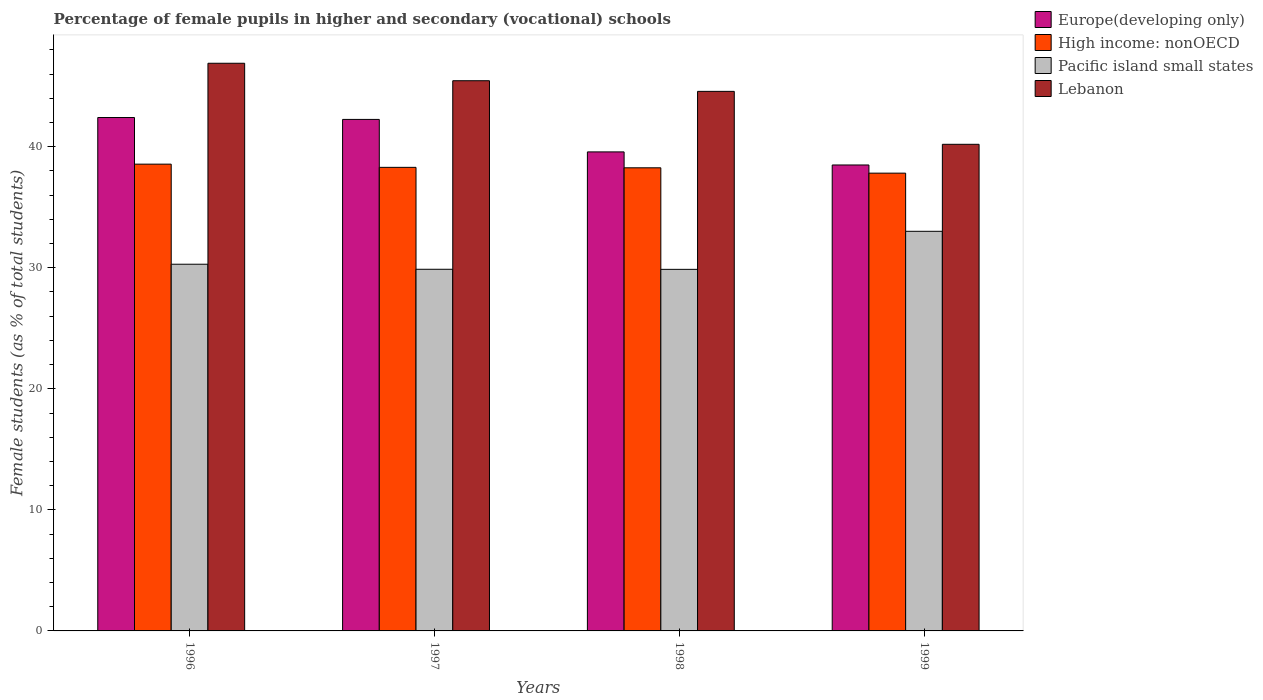How many groups of bars are there?
Ensure brevity in your answer.  4. Are the number of bars per tick equal to the number of legend labels?
Your answer should be compact. Yes. Are the number of bars on each tick of the X-axis equal?
Offer a very short reply. Yes. What is the percentage of female pupils in higher and secondary schools in Pacific island small states in 1999?
Keep it short and to the point. 33.01. Across all years, what is the maximum percentage of female pupils in higher and secondary schools in Lebanon?
Provide a short and direct response. 46.9. Across all years, what is the minimum percentage of female pupils in higher and secondary schools in Europe(developing only)?
Your answer should be very brief. 38.49. In which year was the percentage of female pupils in higher and secondary schools in Europe(developing only) maximum?
Give a very brief answer. 1996. In which year was the percentage of female pupils in higher and secondary schools in Pacific island small states minimum?
Your answer should be compact. 1998. What is the total percentage of female pupils in higher and secondary schools in Europe(developing only) in the graph?
Offer a terse response. 162.74. What is the difference between the percentage of female pupils in higher and secondary schools in Pacific island small states in 1998 and that in 1999?
Ensure brevity in your answer.  -3.14. What is the difference between the percentage of female pupils in higher and secondary schools in High income: nonOECD in 1996 and the percentage of female pupils in higher and secondary schools in Europe(developing only) in 1999?
Provide a short and direct response. 0.07. What is the average percentage of female pupils in higher and secondary schools in Pacific island small states per year?
Offer a very short reply. 30.76. In the year 1996, what is the difference between the percentage of female pupils in higher and secondary schools in High income: nonOECD and percentage of female pupils in higher and secondary schools in Pacific island small states?
Ensure brevity in your answer.  8.27. In how many years, is the percentage of female pupils in higher and secondary schools in Pacific island small states greater than 2 %?
Ensure brevity in your answer.  4. What is the ratio of the percentage of female pupils in higher and secondary schools in Europe(developing only) in 1996 to that in 1997?
Offer a very short reply. 1. What is the difference between the highest and the second highest percentage of female pupils in higher and secondary schools in Europe(developing only)?
Offer a terse response. 0.16. What is the difference between the highest and the lowest percentage of female pupils in higher and secondary schools in Lebanon?
Your response must be concise. 6.7. In how many years, is the percentage of female pupils in higher and secondary schools in High income: nonOECD greater than the average percentage of female pupils in higher and secondary schools in High income: nonOECD taken over all years?
Your answer should be very brief. 3. Is the sum of the percentage of female pupils in higher and secondary schools in Europe(developing only) in 1997 and 1999 greater than the maximum percentage of female pupils in higher and secondary schools in Pacific island small states across all years?
Make the answer very short. Yes. Is it the case that in every year, the sum of the percentage of female pupils in higher and secondary schools in Pacific island small states and percentage of female pupils in higher and secondary schools in Lebanon is greater than the sum of percentage of female pupils in higher and secondary schools in Europe(developing only) and percentage of female pupils in higher and secondary schools in High income: nonOECD?
Your answer should be compact. Yes. What does the 1st bar from the left in 1996 represents?
Offer a terse response. Europe(developing only). What does the 4th bar from the right in 1998 represents?
Give a very brief answer. Europe(developing only). Is it the case that in every year, the sum of the percentage of female pupils in higher and secondary schools in Pacific island small states and percentage of female pupils in higher and secondary schools in High income: nonOECD is greater than the percentage of female pupils in higher and secondary schools in Europe(developing only)?
Offer a terse response. Yes. How many bars are there?
Offer a very short reply. 16. How many years are there in the graph?
Provide a succinct answer. 4. Are the values on the major ticks of Y-axis written in scientific E-notation?
Your answer should be very brief. No. Does the graph contain grids?
Your response must be concise. No. How many legend labels are there?
Your answer should be very brief. 4. How are the legend labels stacked?
Make the answer very short. Vertical. What is the title of the graph?
Offer a very short reply. Percentage of female pupils in higher and secondary (vocational) schools. Does "Kenya" appear as one of the legend labels in the graph?
Offer a very short reply. No. What is the label or title of the Y-axis?
Your answer should be very brief. Female students (as % of total students). What is the Female students (as % of total students) of Europe(developing only) in 1996?
Your answer should be very brief. 42.41. What is the Female students (as % of total students) of High income: nonOECD in 1996?
Offer a very short reply. 38.56. What is the Female students (as % of total students) of Pacific island small states in 1996?
Ensure brevity in your answer.  30.29. What is the Female students (as % of total students) in Lebanon in 1996?
Your answer should be very brief. 46.9. What is the Female students (as % of total students) of Europe(developing only) in 1997?
Give a very brief answer. 42.26. What is the Female students (as % of total students) in High income: nonOECD in 1997?
Ensure brevity in your answer.  38.3. What is the Female students (as % of total students) of Pacific island small states in 1997?
Provide a succinct answer. 29.88. What is the Female students (as % of total students) of Lebanon in 1997?
Provide a succinct answer. 45.45. What is the Female students (as % of total students) in Europe(developing only) in 1998?
Give a very brief answer. 39.57. What is the Female students (as % of total students) of High income: nonOECD in 1998?
Offer a very short reply. 38.26. What is the Female students (as % of total students) of Pacific island small states in 1998?
Your answer should be very brief. 29.87. What is the Female students (as % of total students) in Lebanon in 1998?
Make the answer very short. 44.57. What is the Female students (as % of total students) of Europe(developing only) in 1999?
Your answer should be compact. 38.49. What is the Female students (as % of total students) of High income: nonOECD in 1999?
Your answer should be compact. 37.82. What is the Female students (as % of total students) of Pacific island small states in 1999?
Offer a very short reply. 33.01. What is the Female students (as % of total students) of Lebanon in 1999?
Offer a very short reply. 40.2. Across all years, what is the maximum Female students (as % of total students) in Europe(developing only)?
Your answer should be very brief. 42.41. Across all years, what is the maximum Female students (as % of total students) in High income: nonOECD?
Give a very brief answer. 38.56. Across all years, what is the maximum Female students (as % of total students) in Pacific island small states?
Make the answer very short. 33.01. Across all years, what is the maximum Female students (as % of total students) of Lebanon?
Keep it short and to the point. 46.9. Across all years, what is the minimum Female students (as % of total students) of Europe(developing only)?
Ensure brevity in your answer.  38.49. Across all years, what is the minimum Female students (as % of total students) of High income: nonOECD?
Keep it short and to the point. 37.82. Across all years, what is the minimum Female students (as % of total students) in Pacific island small states?
Your answer should be very brief. 29.87. Across all years, what is the minimum Female students (as % of total students) in Lebanon?
Provide a short and direct response. 40.2. What is the total Female students (as % of total students) of Europe(developing only) in the graph?
Offer a terse response. 162.74. What is the total Female students (as % of total students) in High income: nonOECD in the graph?
Provide a short and direct response. 152.94. What is the total Female students (as % of total students) of Pacific island small states in the graph?
Provide a short and direct response. 123.06. What is the total Female students (as % of total students) in Lebanon in the graph?
Your answer should be compact. 177.13. What is the difference between the Female students (as % of total students) in Europe(developing only) in 1996 and that in 1997?
Your answer should be compact. 0.16. What is the difference between the Female students (as % of total students) of High income: nonOECD in 1996 and that in 1997?
Offer a very short reply. 0.26. What is the difference between the Female students (as % of total students) of Pacific island small states in 1996 and that in 1997?
Offer a terse response. 0.42. What is the difference between the Female students (as % of total students) in Lebanon in 1996 and that in 1997?
Ensure brevity in your answer.  1.44. What is the difference between the Female students (as % of total students) of Europe(developing only) in 1996 and that in 1998?
Your answer should be very brief. 2.84. What is the difference between the Female students (as % of total students) of High income: nonOECD in 1996 and that in 1998?
Give a very brief answer. 0.3. What is the difference between the Female students (as % of total students) in Pacific island small states in 1996 and that in 1998?
Make the answer very short. 0.42. What is the difference between the Female students (as % of total students) of Lebanon in 1996 and that in 1998?
Make the answer very short. 2.32. What is the difference between the Female students (as % of total students) in Europe(developing only) in 1996 and that in 1999?
Your response must be concise. 3.92. What is the difference between the Female students (as % of total students) of High income: nonOECD in 1996 and that in 1999?
Provide a succinct answer. 0.74. What is the difference between the Female students (as % of total students) in Pacific island small states in 1996 and that in 1999?
Ensure brevity in your answer.  -2.72. What is the difference between the Female students (as % of total students) of Lebanon in 1996 and that in 1999?
Keep it short and to the point. 6.7. What is the difference between the Female students (as % of total students) of Europe(developing only) in 1997 and that in 1998?
Offer a terse response. 2.68. What is the difference between the Female students (as % of total students) of High income: nonOECD in 1997 and that in 1998?
Offer a terse response. 0.04. What is the difference between the Female students (as % of total students) in Pacific island small states in 1997 and that in 1998?
Provide a short and direct response. 0.01. What is the difference between the Female students (as % of total students) in Lebanon in 1997 and that in 1998?
Provide a succinct answer. 0.88. What is the difference between the Female students (as % of total students) in Europe(developing only) in 1997 and that in 1999?
Your response must be concise. 3.76. What is the difference between the Female students (as % of total students) of High income: nonOECD in 1997 and that in 1999?
Provide a succinct answer. 0.48. What is the difference between the Female students (as % of total students) of Pacific island small states in 1997 and that in 1999?
Ensure brevity in your answer.  -3.14. What is the difference between the Female students (as % of total students) of Lebanon in 1997 and that in 1999?
Provide a succinct answer. 5.25. What is the difference between the Female students (as % of total students) in Europe(developing only) in 1998 and that in 1999?
Give a very brief answer. 1.08. What is the difference between the Female students (as % of total students) in High income: nonOECD in 1998 and that in 1999?
Make the answer very short. 0.44. What is the difference between the Female students (as % of total students) of Pacific island small states in 1998 and that in 1999?
Keep it short and to the point. -3.14. What is the difference between the Female students (as % of total students) in Lebanon in 1998 and that in 1999?
Offer a terse response. 4.37. What is the difference between the Female students (as % of total students) of Europe(developing only) in 1996 and the Female students (as % of total students) of High income: nonOECD in 1997?
Offer a very short reply. 4.12. What is the difference between the Female students (as % of total students) of Europe(developing only) in 1996 and the Female students (as % of total students) of Pacific island small states in 1997?
Make the answer very short. 12.54. What is the difference between the Female students (as % of total students) of Europe(developing only) in 1996 and the Female students (as % of total students) of Lebanon in 1997?
Your answer should be compact. -3.04. What is the difference between the Female students (as % of total students) of High income: nonOECD in 1996 and the Female students (as % of total students) of Pacific island small states in 1997?
Offer a terse response. 8.69. What is the difference between the Female students (as % of total students) of High income: nonOECD in 1996 and the Female students (as % of total students) of Lebanon in 1997?
Offer a very short reply. -6.89. What is the difference between the Female students (as % of total students) of Pacific island small states in 1996 and the Female students (as % of total students) of Lebanon in 1997?
Keep it short and to the point. -15.16. What is the difference between the Female students (as % of total students) in Europe(developing only) in 1996 and the Female students (as % of total students) in High income: nonOECD in 1998?
Your response must be concise. 4.15. What is the difference between the Female students (as % of total students) of Europe(developing only) in 1996 and the Female students (as % of total students) of Pacific island small states in 1998?
Your answer should be very brief. 12.54. What is the difference between the Female students (as % of total students) in Europe(developing only) in 1996 and the Female students (as % of total students) in Lebanon in 1998?
Your answer should be very brief. -2.16. What is the difference between the Female students (as % of total students) in High income: nonOECD in 1996 and the Female students (as % of total students) in Pacific island small states in 1998?
Offer a terse response. 8.69. What is the difference between the Female students (as % of total students) of High income: nonOECD in 1996 and the Female students (as % of total students) of Lebanon in 1998?
Make the answer very short. -6.01. What is the difference between the Female students (as % of total students) in Pacific island small states in 1996 and the Female students (as % of total students) in Lebanon in 1998?
Ensure brevity in your answer.  -14.28. What is the difference between the Female students (as % of total students) of Europe(developing only) in 1996 and the Female students (as % of total students) of High income: nonOECD in 1999?
Provide a short and direct response. 4.6. What is the difference between the Female students (as % of total students) in Europe(developing only) in 1996 and the Female students (as % of total students) in Pacific island small states in 1999?
Your response must be concise. 9.4. What is the difference between the Female students (as % of total students) of Europe(developing only) in 1996 and the Female students (as % of total students) of Lebanon in 1999?
Give a very brief answer. 2.21. What is the difference between the Female students (as % of total students) in High income: nonOECD in 1996 and the Female students (as % of total students) in Pacific island small states in 1999?
Provide a short and direct response. 5.55. What is the difference between the Female students (as % of total students) in High income: nonOECD in 1996 and the Female students (as % of total students) in Lebanon in 1999?
Give a very brief answer. -1.64. What is the difference between the Female students (as % of total students) in Pacific island small states in 1996 and the Female students (as % of total students) in Lebanon in 1999?
Provide a succinct answer. -9.91. What is the difference between the Female students (as % of total students) of Europe(developing only) in 1997 and the Female students (as % of total students) of High income: nonOECD in 1998?
Provide a short and direct response. 4. What is the difference between the Female students (as % of total students) in Europe(developing only) in 1997 and the Female students (as % of total students) in Pacific island small states in 1998?
Ensure brevity in your answer.  12.39. What is the difference between the Female students (as % of total students) of Europe(developing only) in 1997 and the Female students (as % of total students) of Lebanon in 1998?
Give a very brief answer. -2.32. What is the difference between the Female students (as % of total students) in High income: nonOECD in 1997 and the Female students (as % of total students) in Pacific island small states in 1998?
Offer a very short reply. 8.43. What is the difference between the Female students (as % of total students) in High income: nonOECD in 1997 and the Female students (as % of total students) in Lebanon in 1998?
Provide a succinct answer. -6.28. What is the difference between the Female students (as % of total students) of Pacific island small states in 1997 and the Female students (as % of total students) of Lebanon in 1998?
Offer a terse response. -14.7. What is the difference between the Female students (as % of total students) in Europe(developing only) in 1997 and the Female students (as % of total students) in High income: nonOECD in 1999?
Provide a succinct answer. 4.44. What is the difference between the Female students (as % of total students) in Europe(developing only) in 1997 and the Female students (as % of total students) in Pacific island small states in 1999?
Give a very brief answer. 9.24. What is the difference between the Female students (as % of total students) of Europe(developing only) in 1997 and the Female students (as % of total students) of Lebanon in 1999?
Provide a succinct answer. 2.06. What is the difference between the Female students (as % of total students) in High income: nonOECD in 1997 and the Female students (as % of total students) in Pacific island small states in 1999?
Provide a short and direct response. 5.28. What is the difference between the Female students (as % of total students) of High income: nonOECD in 1997 and the Female students (as % of total students) of Lebanon in 1999?
Provide a succinct answer. -1.9. What is the difference between the Female students (as % of total students) in Pacific island small states in 1997 and the Female students (as % of total students) in Lebanon in 1999?
Your response must be concise. -10.32. What is the difference between the Female students (as % of total students) of Europe(developing only) in 1998 and the Female students (as % of total students) of High income: nonOECD in 1999?
Make the answer very short. 1.76. What is the difference between the Female students (as % of total students) of Europe(developing only) in 1998 and the Female students (as % of total students) of Pacific island small states in 1999?
Your answer should be very brief. 6.56. What is the difference between the Female students (as % of total students) of Europe(developing only) in 1998 and the Female students (as % of total students) of Lebanon in 1999?
Ensure brevity in your answer.  -0.63. What is the difference between the Female students (as % of total students) of High income: nonOECD in 1998 and the Female students (as % of total students) of Pacific island small states in 1999?
Your answer should be very brief. 5.24. What is the difference between the Female students (as % of total students) of High income: nonOECD in 1998 and the Female students (as % of total students) of Lebanon in 1999?
Give a very brief answer. -1.94. What is the difference between the Female students (as % of total students) in Pacific island small states in 1998 and the Female students (as % of total students) in Lebanon in 1999?
Give a very brief answer. -10.33. What is the average Female students (as % of total students) of Europe(developing only) per year?
Make the answer very short. 40.68. What is the average Female students (as % of total students) in High income: nonOECD per year?
Make the answer very short. 38.23. What is the average Female students (as % of total students) in Pacific island small states per year?
Provide a succinct answer. 30.76. What is the average Female students (as % of total students) of Lebanon per year?
Your answer should be compact. 44.28. In the year 1996, what is the difference between the Female students (as % of total students) of Europe(developing only) and Female students (as % of total students) of High income: nonOECD?
Your answer should be compact. 3.85. In the year 1996, what is the difference between the Female students (as % of total students) of Europe(developing only) and Female students (as % of total students) of Pacific island small states?
Offer a very short reply. 12.12. In the year 1996, what is the difference between the Female students (as % of total students) in Europe(developing only) and Female students (as % of total students) in Lebanon?
Provide a succinct answer. -4.48. In the year 1996, what is the difference between the Female students (as % of total students) of High income: nonOECD and Female students (as % of total students) of Pacific island small states?
Give a very brief answer. 8.27. In the year 1996, what is the difference between the Female students (as % of total students) of High income: nonOECD and Female students (as % of total students) of Lebanon?
Make the answer very short. -8.34. In the year 1996, what is the difference between the Female students (as % of total students) of Pacific island small states and Female students (as % of total students) of Lebanon?
Provide a short and direct response. -16.6. In the year 1997, what is the difference between the Female students (as % of total students) of Europe(developing only) and Female students (as % of total students) of High income: nonOECD?
Offer a terse response. 3.96. In the year 1997, what is the difference between the Female students (as % of total students) of Europe(developing only) and Female students (as % of total students) of Pacific island small states?
Keep it short and to the point. 12.38. In the year 1997, what is the difference between the Female students (as % of total students) of Europe(developing only) and Female students (as % of total students) of Lebanon?
Keep it short and to the point. -3.2. In the year 1997, what is the difference between the Female students (as % of total students) of High income: nonOECD and Female students (as % of total students) of Pacific island small states?
Your answer should be very brief. 8.42. In the year 1997, what is the difference between the Female students (as % of total students) in High income: nonOECD and Female students (as % of total students) in Lebanon?
Your answer should be very brief. -7.16. In the year 1997, what is the difference between the Female students (as % of total students) in Pacific island small states and Female students (as % of total students) in Lebanon?
Provide a short and direct response. -15.58. In the year 1998, what is the difference between the Female students (as % of total students) of Europe(developing only) and Female students (as % of total students) of High income: nonOECD?
Keep it short and to the point. 1.31. In the year 1998, what is the difference between the Female students (as % of total students) in Europe(developing only) and Female students (as % of total students) in Pacific island small states?
Offer a very short reply. 9.7. In the year 1998, what is the difference between the Female students (as % of total students) of Europe(developing only) and Female students (as % of total students) of Lebanon?
Give a very brief answer. -5. In the year 1998, what is the difference between the Female students (as % of total students) in High income: nonOECD and Female students (as % of total students) in Pacific island small states?
Your answer should be very brief. 8.39. In the year 1998, what is the difference between the Female students (as % of total students) of High income: nonOECD and Female students (as % of total students) of Lebanon?
Offer a very short reply. -6.32. In the year 1998, what is the difference between the Female students (as % of total students) of Pacific island small states and Female students (as % of total students) of Lebanon?
Your answer should be compact. -14.7. In the year 1999, what is the difference between the Female students (as % of total students) in Europe(developing only) and Female students (as % of total students) in High income: nonOECD?
Offer a very short reply. 0.68. In the year 1999, what is the difference between the Female students (as % of total students) in Europe(developing only) and Female students (as % of total students) in Pacific island small states?
Your answer should be compact. 5.48. In the year 1999, what is the difference between the Female students (as % of total students) in Europe(developing only) and Female students (as % of total students) in Lebanon?
Ensure brevity in your answer.  -1.71. In the year 1999, what is the difference between the Female students (as % of total students) in High income: nonOECD and Female students (as % of total students) in Pacific island small states?
Your answer should be compact. 4.8. In the year 1999, what is the difference between the Female students (as % of total students) of High income: nonOECD and Female students (as % of total students) of Lebanon?
Ensure brevity in your answer.  -2.38. In the year 1999, what is the difference between the Female students (as % of total students) in Pacific island small states and Female students (as % of total students) in Lebanon?
Ensure brevity in your answer.  -7.19. What is the ratio of the Female students (as % of total students) of Europe(developing only) in 1996 to that in 1997?
Ensure brevity in your answer.  1. What is the ratio of the Female students (as % of total students) in Pacific island small states in 1996 to that in 1997?
Keep it short and to the point. 1.01. What is the ratio of the Female students (as % of total students) of Lebanon in 1996 to that in 1997?
Provide a succinct answer. 1.03. What is the ratio of the Female students (as % of total students) in Europe(developing only) in 1996 to that in 1998?
Keep it short and to the point. 1.07. What is the ratio of the Female students (as % of total students) in High income: nonOECD in 1996 to that in 1998?
Provide a succinct answer. 1.01. What is the ratio of the Female students (as % of total students) in Pacific island small states in 1996 to that in 1998?
Your answer should be very brief. 1.01. What is the ratio of the Female students (as % of total students) of Lebanon in 1996 to that in 1998?
Give a very brief answer. 1.05. What is the ratio of the Female students (as % of total students) of Europe(developing only) in 1996 to that in 1999?
Offer a terse response. 1.1. What is the ratio of the Female students (as % of total students) of High income: nonOECD in 1996 to that in 1999?
Your answer should be compact. 1.02. What is the ratio of the Female students (as % of total students) in Pacific island small states in 1996 to that in 1999?
Your answer should be very brief. 0.92. What is the ratio of the Female students (as % of total students) in Lebanon in 1996 to that in 1999?
Offer a very short reply. 1.17. What is the ratio of the Female students (as % of total students) of Europe(developing only) in 1997 to that in 1998?
Offer a terse response. 1.07. What is the ratio of the Female students (as % of total students) in Lebanon in 1997 to that in 1998?
Provide a succinct answer. 1.02. What is the ratio of the Female students (as % of total students) in Europe(developing only) in 1997 to that in 1999?
Give a very brief answer. 1.1. What is the ratio of the Female students (as % of total students) in High income: nonOECD in 1997 to that in 1999?
Your response must be concise. 1.01. What is the ratio of the Female students (as % of total students) in Pacific island small states in 1997 to that in 1999?
Give a very brief answer. 0.91. What is the ratio of the Female students (as % of total students) in Lebanon in 1997 to that in 1999?
Your answer should be compact. 1.13. What is the ratio of the Female students (as % of total students) in Europe(developing only) in 1998 to that in 1999?
Keep it short and to the point. 1.03. What is the ratio of the Female students (as % of total students) in High income: nonOECD in 1998 to that in 1999?
Provide a succinct answer. 1.01. What is the ratio of the Female students (as % of total students) of Pacific island small states in 1998 to that in 1999?
Provide a succinct answer. 0.9. What is the ratio of the Female students (as % of total students) in Lebanon in 1998 to that in 1999?
Your answer should be compact. 1.11. What is the difference between the highest and the second highest Female students (as % of total students) of Europe(developing only)?
Provide a succinct answer. 0.16. What is the difference between the highest and the second highest Female students (as % of total students) in High income: nonOECD?
Give a very brief answer. 0.26. What is the difference between the highest and the second highest Female students (as % of total students) of Pacific island small states?
Provide a succinct answer. 2.72. What is the difference between the highest and the second highest Female students (as % of total students) in Lebanon?
Ensure brevity in your answer.  1.44. What is the difference between the highest and the lowest Female students (as % of total students) of Europe(developing only)?
Your response must be concise. 3.92. What is the difference between the highest and the lowest Female students (as % of total students) in High income: nonOECD?
Your answer should be compact. 0.74. What is the difference between the highest and the lowest Female students (as % of total students) in Pacific island small states?
Keep it short and to the point. 3.14. What is the difference between the highest and the lowest Female students (as % of total students) in Lebanon?
Make the answer very short. 6.7. 